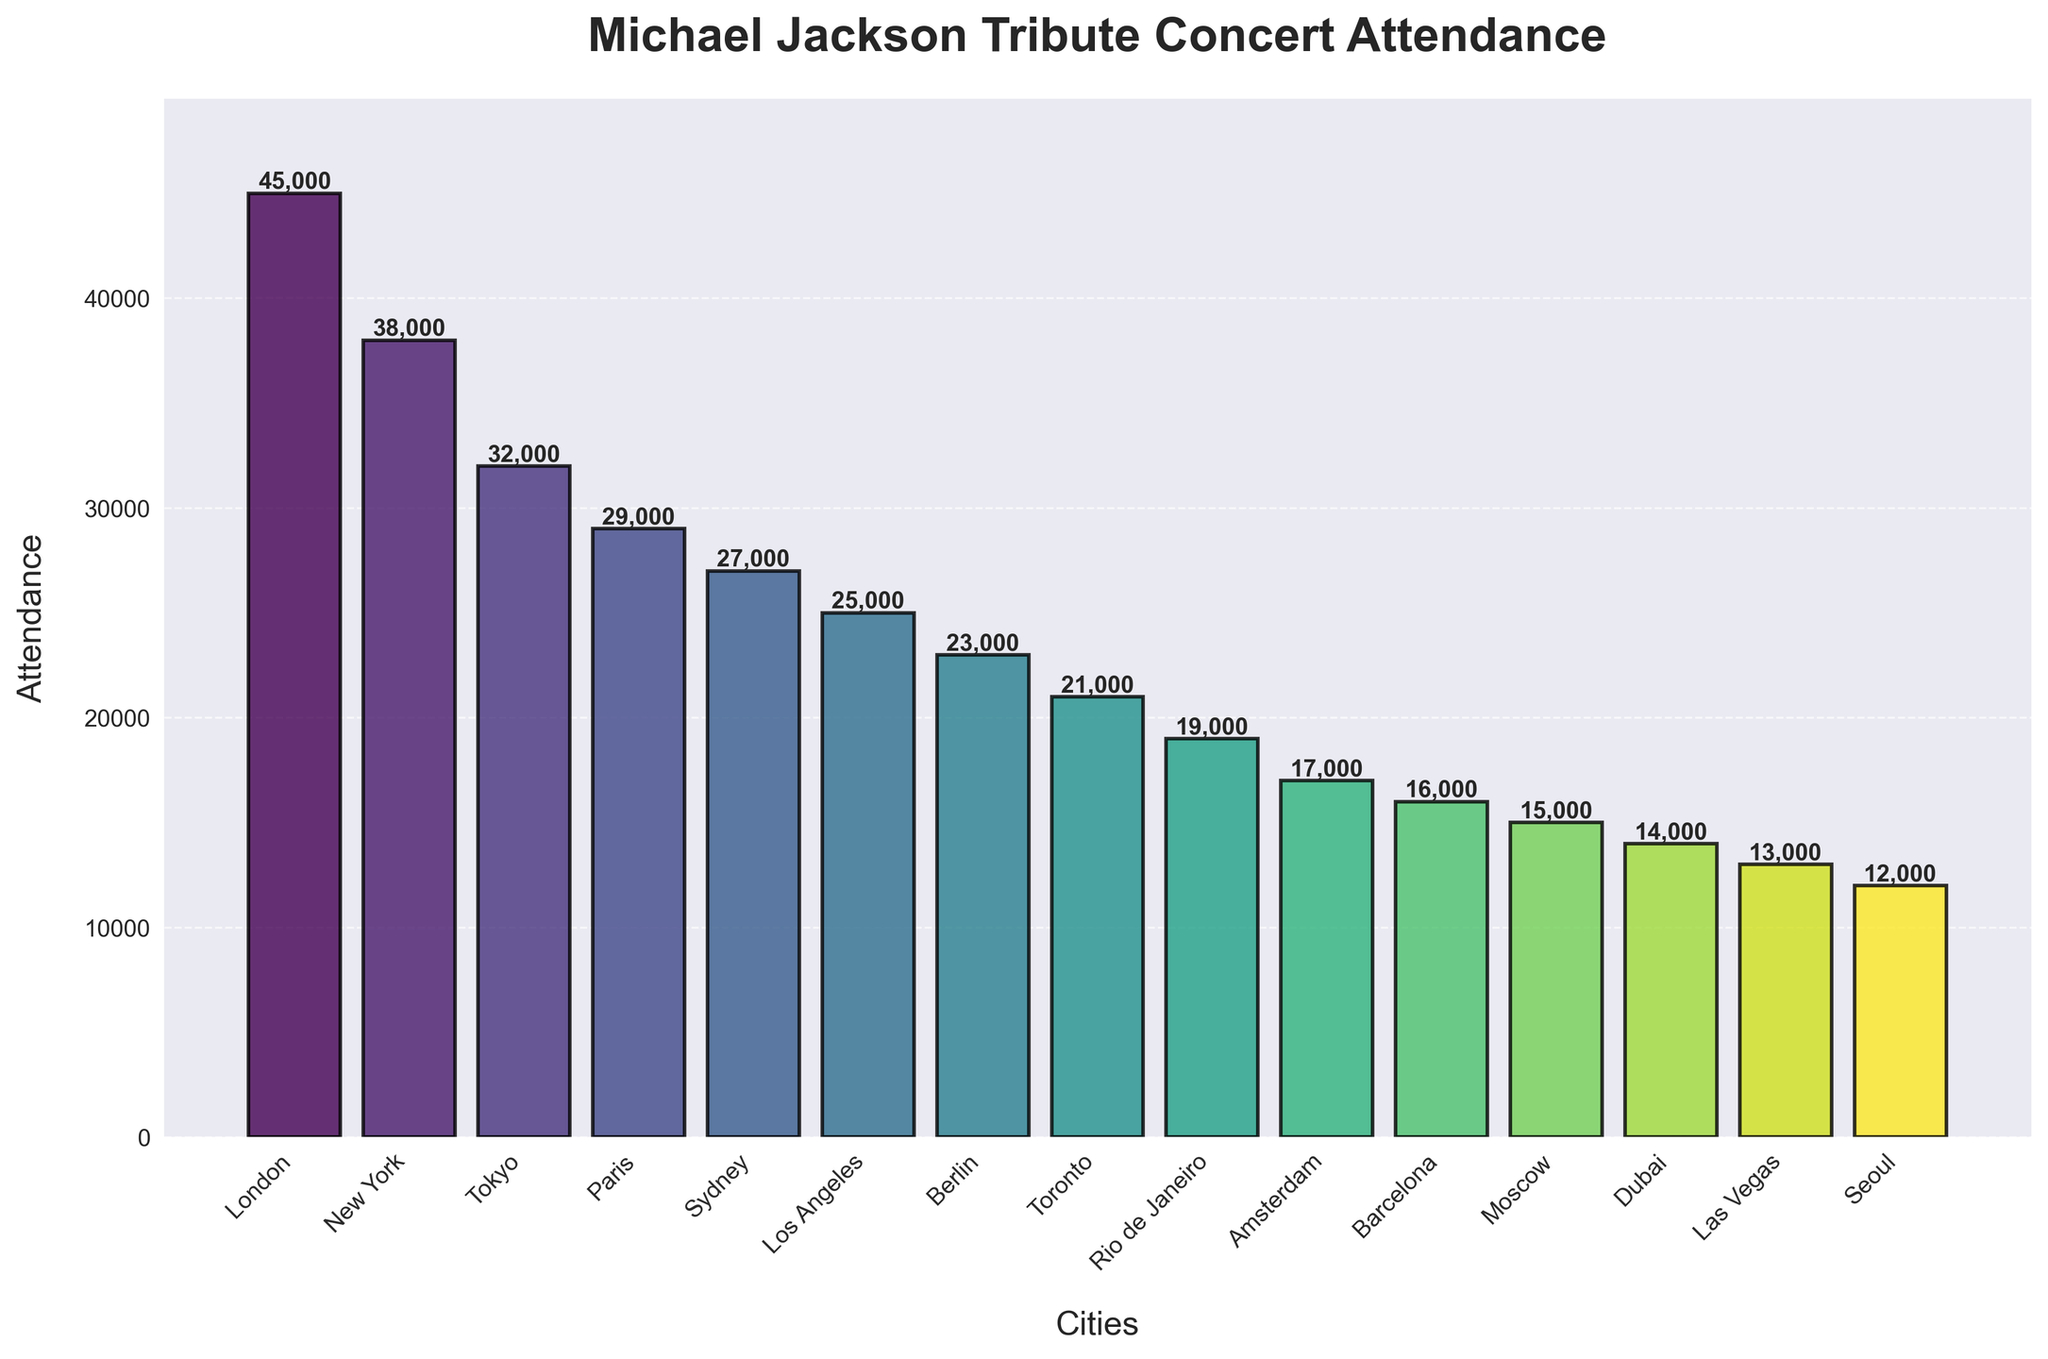Which city had the highest attendance? From the figure, the tallest bar represents London, indicating it had the highest attendance.
Answer: London What is the attendance difference between the concerts in Paris and Los Angeles? The figure shows Paris had 29,000 attendees and Los Angeles had 25,000 attendees. Subtracting the attendance of Los Angeles from Paris gives 29,000 - 25,000 = 4,000.
Answer: 4,000 Which city had the lowest attendance, and how many people attended? The shortest bar represents Seoul, indicating it had the lowest attendance of 12,000.
Answer: Seoul, 12,000 What is the total attendance for the top three cities by attendance? The top three cities by attendance are London (45,000), New York (38,000), and Tokyo (32,000). Adding these gives 45,000 + 38,000 + 32,000 = 115,000.
Answer: 115,000 How does the attendance in Berlin compare to Rio de Janeiro? Berlin had an attendance of 23,000 while Rio de Janeiro had 19,000. Berlin's attendance is higher by 4,000.
Answer: 4,000 more in Berlin Which city had an attendance closest to 20,000? The figure shows that Toronto had an attendance of 21,000, which is the closest to 20,000.
Answer: Toronto What are the average attendance figures for the concerts in Tokyo, Paris, and Sydney? The attendance figures are Tokyo (32,000), Paris (29,000), and Sydney (27,000). The sum is 32,000 + 29,000 + 27,000 = 88,000. There are three cities, so the average is 88,000 / 3 = 29,333.33.
Answer: 29,333 How many cities had attendances greater than 30,000? By inspecting the figure, London, New York, and Tokyo had attendances greater than 30,000. That’s 3 cities.
Answer: 3 Rank the first five cities from highest to lowest attendance. The first five cities by attendance are London (45,000), New York (38,000), Tokyo (32,000), Paris (29,000), and Sydney (27,000).
Answer: London, New York, Tokyo, Paris, Sydney What is the combined attendance for concerts in all the cities shown on the plot? Sum the attendances for all cities: 45,000 + 38,000 + 32,000 + 29,000 + 27,000 + 25,000 + 23,000 + 21,000 + 19,000 + 17,000 + 16,000 + 15,000 + 14,000 + 13,000 + 12,000 = 366,000.
Answer: 366,000 